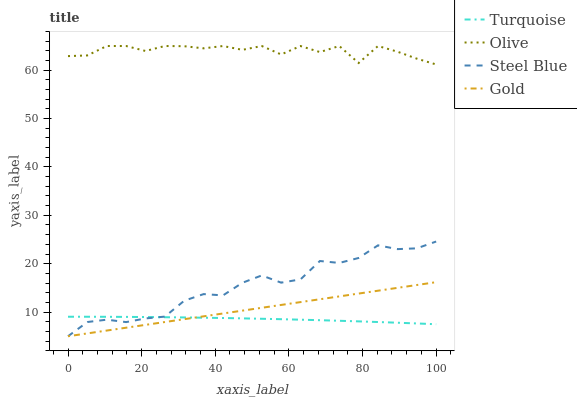Does Turquoise have the minimum area under the curve?
Answer yes or no. Yes. Does Olive have the maximum area under the curve?
Answer yes or no. Yes. Does Steel Blue have the minimum area under the curve?
Answer yes or no. No. Does Steel Blue have the maximum area under the curve?
Answer yes or no. No. Is Gold the smoothest?
Answer yes or no. Yes. Is Olive the roughest?
Answer yes or no. Yes. Is Turquoise the smoothest?
Answer yes or no. No. Is Turquoise the roughest?
Answer yes or no. No. Does Turquoise have the lowest value?
Answer yes or no. No. Does Olive have the highest value?
Answer yes or no. Yes. Does Steel Blue have the highest value?
Answer yes or no. No. Is Steel Blue less than Olive?
Answer yes or no. Yes. Is Olive greater than Turquoise?
Answer yes or no. Yes. Does Steel Blue intersect Turquoise?
Answer yes or no. Yes. Is Steel Blue less than Turquoise?
Answer yes or no. No. Is Steel Blue greater than Turquoise?
Answer yes or no. No. Does Steel Blue intersect Olive?
Answer yes or no. No. 